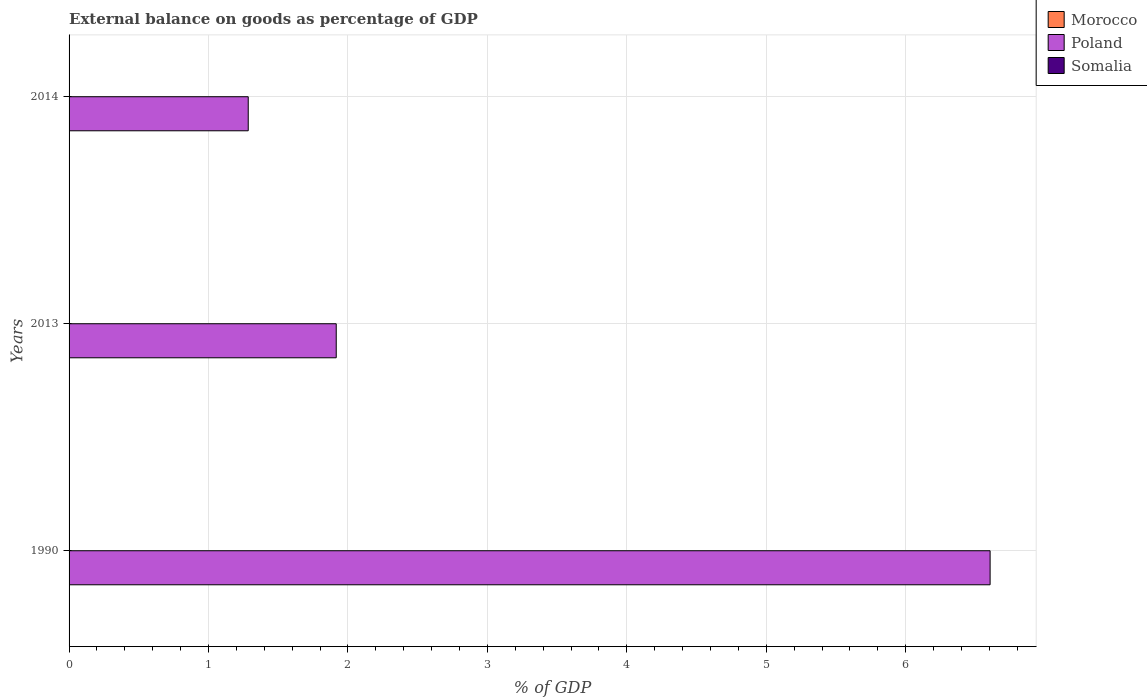How many different coloured bars are there?
Offer a very short reply. 1. Are the number of bars per tick equal to the number of legend labels?
Make the answer very short. No. Are the number of bars on each tick of the Y-axis equal?
Offer a terse response. Yes. How many bars are there on the 3rd tick from the bottom?
Your answer should be compact. 1. What is the external balance on goods as percentage of GDP in Somalia in 2014?
Your response must be concise. 0. Across all years, what is the maximum external balance on goods as percentage of GDP in Poland?
Offer a very short reply. 6.61. What is the difference between the external balance on goods as percentage of GDP in Poland in 2013 and that in 2014?
Provide a short and direct response. 0.63. What is the average external balance on goods as percentage of GDP in Morocco per year?
Your response must be concise. 0. In how many years, is the external balance on goods as percentage of GDP in Poland greater than 4.2 %?
Provide a succinct answer. 1. What is the ratio of the external balance on goods as percentage of GDP in Poland in 1990 to that in 2014?
Make the answer very short. 5.14. Is the external balance on goods as percentage of GDP in Poland in 1990 less than that in 2013?
Provide a succinct answer. No. What is the difference between the highest and the lowest external balance on goods as percentage of GDP in Poland?
Provide a succinct answer. 5.32. Are all the bars in the graph horizontal?
Provide a succinct answer. Yes. How many years are there in the graph?
Provide a short and direct response. 3. What is the difference between two consecutive major ticks on the X-axis?
Offer a terse response. 1. Does the graph contain grids?
Your answer should be compact. Yes. What is the title of the graph?
Ensure brevity in your answer.  External balance on goods as percentage of GDP. Does "Bangladesh" appear as one of the legend labels in the graph?
Make the answer very short. No. What is the label or title of the X-axis?
Ensure brevity in your answer.  % of GDP. What is the % of GDP of Poland in 1990?
Provide a short and direct response. 6.61. What is the % of GDP in Poland in 2013?
Provide a short and direct response. 1.92. What is the % of GDP of Somalia in 2013?
Offer a very short reply. 0. What is the % of GDP in Poland in 2014?
Provide a short and direct response. 1.28. Across all years, what is the maximum % of GDP in Poland?
Make the answer very short. 6.61. Across all years, what is the minimum % of GDP in Poland?
Give a very brief answer. 1.28. What is the total % of GDP in Poland in the graph?
Your response must be concise. 9.81. What is the difference between the % of GDP in Poland in 1990 and that in 2013?
Your answer should be compact. 4.69. What is the difference between the % of GDP in Poland in 1990 and that in 2014?
Keep it short and to the point. 5.32. What is the difference between the % of GDP of Poland in 2013 and that in 2014?
Your answer should be compact. 0.63. What is the average % of GDP of Morocco per year?
Provide a short and direct response. 0. What is the average % of GDP of Poland per year?
Make the answer very short. 3.27. What is the average % of GDP of Somalia per year?
Keep it short and to the point. 0. What is the ratio of the % of GDP of Poland in 1990 to that in 2013?
Your answer should be compact. 3.45. What is the ratio of the % of GDP of Poland in 1990 to that in 2014?
Provide a short and direct response. 5.14. What is the ratio of the % of GDP in Poland in 2013 to that in 2014?
Ensure brevity in your answer.  1.49. What is the difference between the highest and the second highest % of GDP in Poland?
Give a very brief answer. 4.69. What is the difference between the highest and the lowest % of GDP of Poland?
Offer a very short reply. 5.32. 